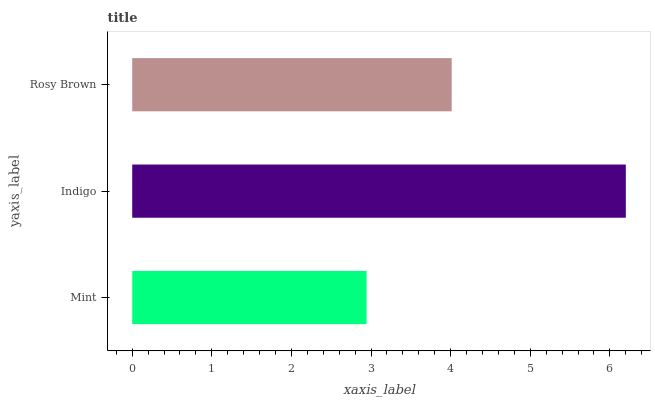Is Mint the minimum?
Answer yes or no. Yes. Is Indigo the maximum?
Answer yes or no. Yes. Is Rosy Brown the minimum?
Answer yes or no. No. Is Rosy Brown the maximum?
Answer yes or no. No. Is Indigo greater than Rosy Brown?
Answer yes or no. Yes. Is Rosy Brown less than Indigo?
Answer yes or no. Yes. Is Rosy Brown greater than Indigo?
Answer yes or no. No. Is Indigo less than Rosy Brown?
Answer yes or no. No. Is Rosy Brown the high median?
Answer yes or no. Yes. Is Rosy Brown the low median?
Answer yes or no. Yes. Is Mint the high median?
Answer yes or no. No. Is Indigo the low median?
Answer yes or no. No. 